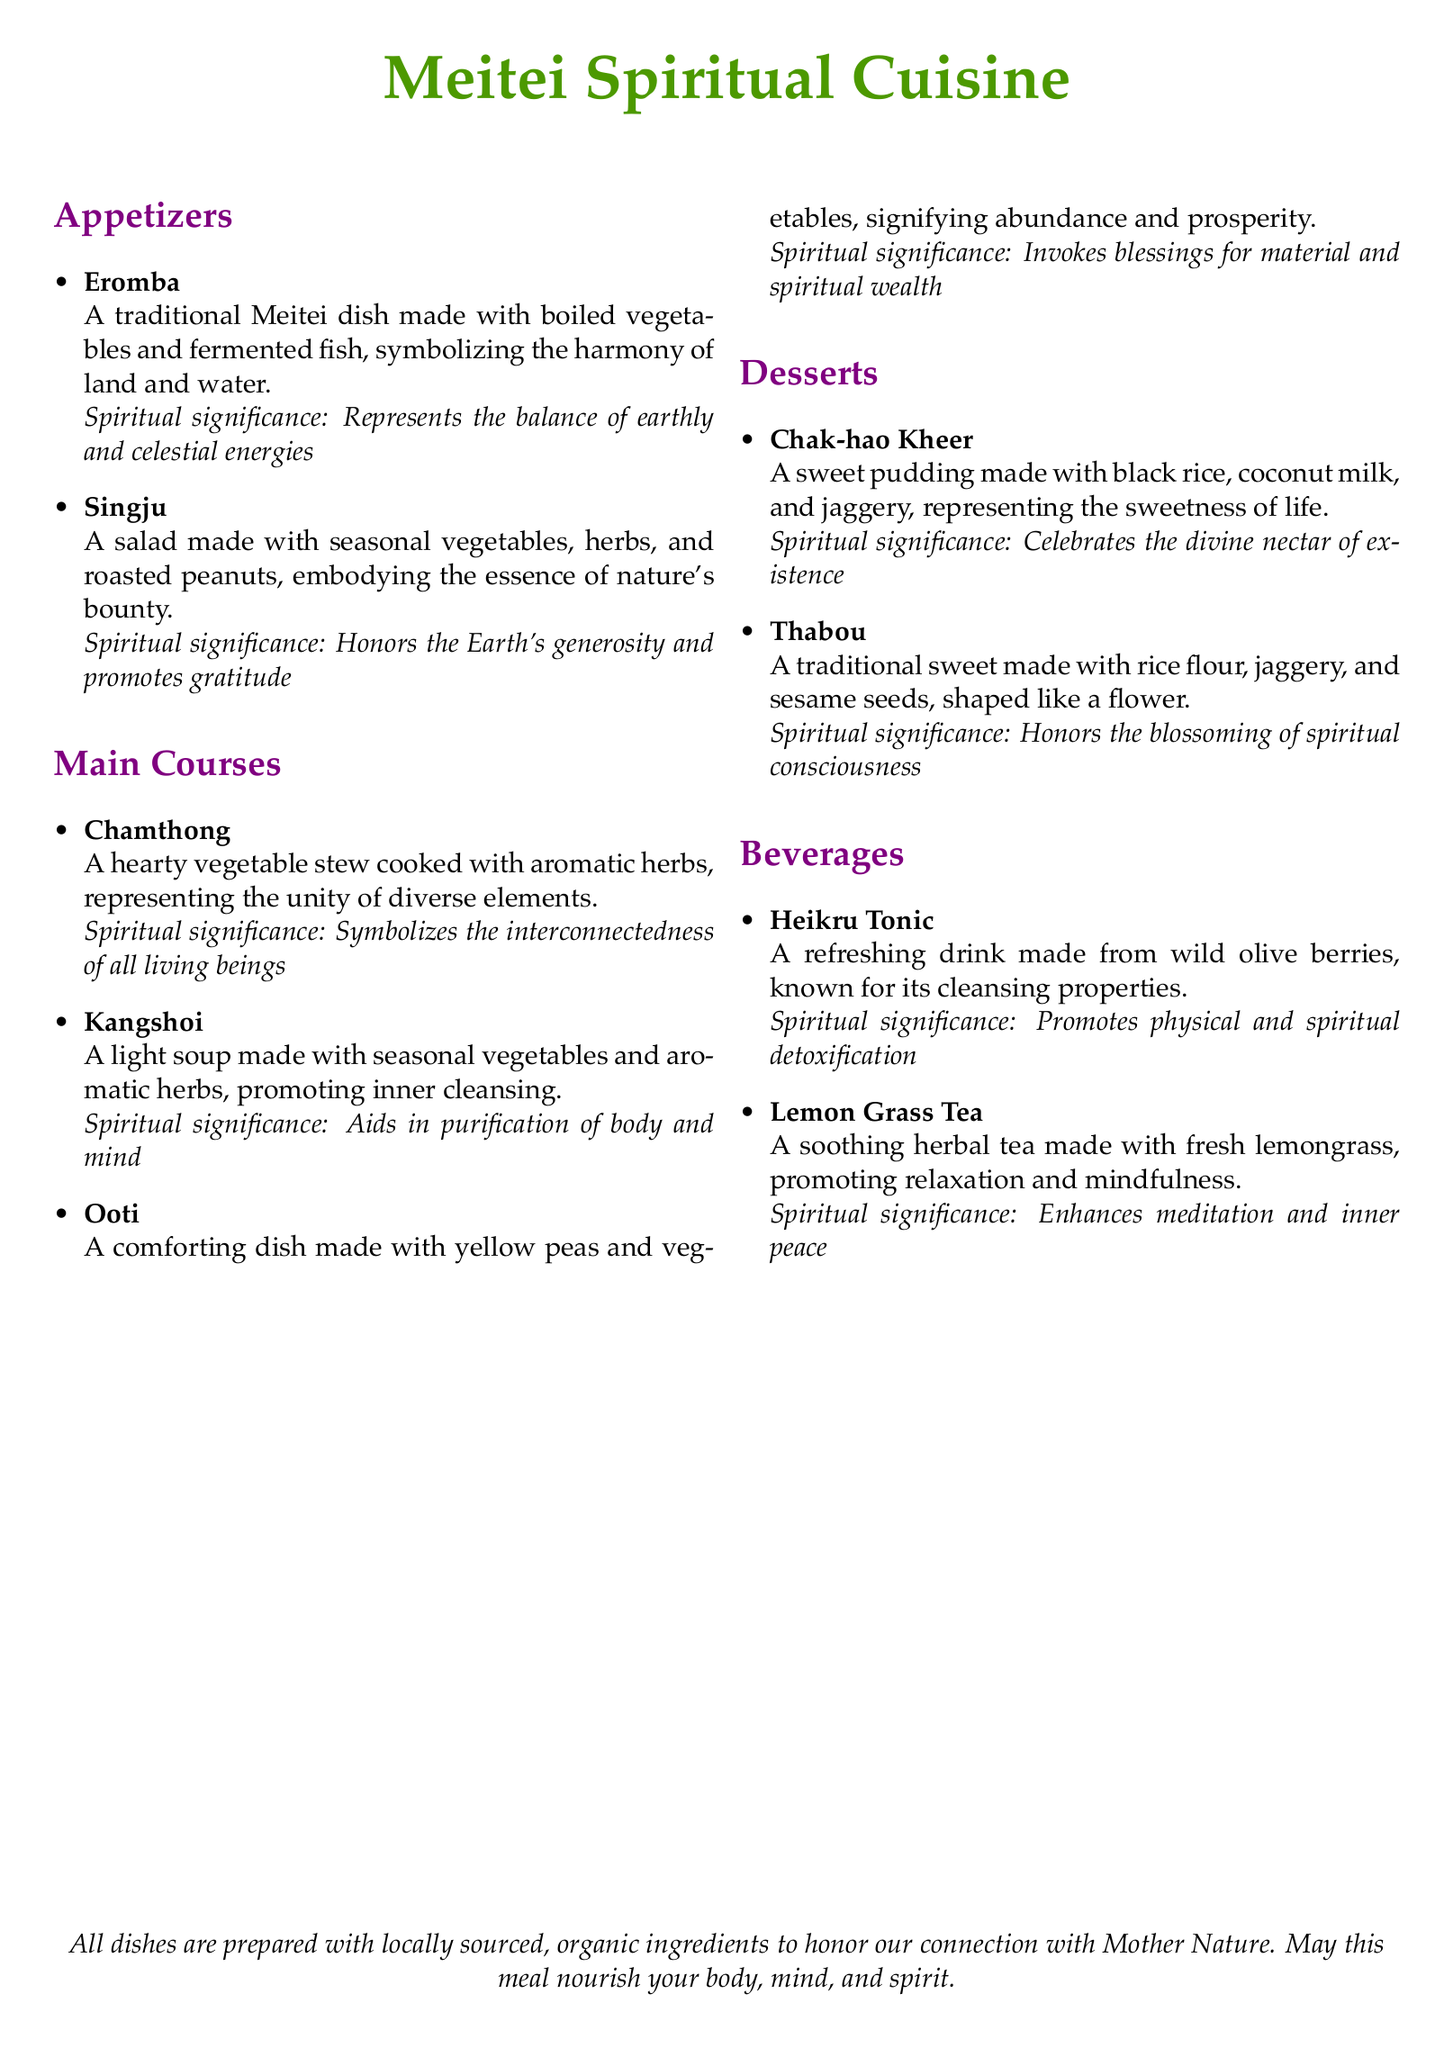what is the name of the dessert made with black rice? The dessert is called Chak-hao Kheer, which is mentioned in the desserts section of the menu.
Answer: Chak-hao Kheer how many appetizers are listed on the menu? The menu lists two appetizers: Eromba and Singju, as seen in the appetizers section.
Answer: 2 what does Chamthong represent? Chamthong represents the unity of diverse elements, as stated in the main courses section of the menu.
Answer: Unity of diverse elements what is the spiritual significance of Heikru Tonic? The spiritual significance of Heikru Tonic is that it promotes physical and spiritual detoxification, according to the beverages section.
Answer: Promotes physical and spiritual detoxification what are the two main courses that signify abundance and prosperity? The main course that signifies abundance and prosperity is Ooti, as noted in the menu.
Answer: Ooti which ingredient is used in Chak-hao Kheer? Chak-hao Kheer is made with black rice, as listed in the desserts section of the menu.
Answer: Black rice what is the main vegetable in Kangshoi? Kangshoi is made with seasonal vegetables, which is stated in the main courses section of the menu.
Answer: Seasonal vegetables which dish embodies the essence of nature's bounty? Singju embodies the essence of nature's bounty, as highlighted in the appetizers section.
Answer: Singju what is the primary flavoring used in Lemon Grass Tea? The primary flavoring used in Lemon Grass Tea is fresh lemongrass, mentioned in the beverages section of the menu.
Answer: Fresh lemongrass 